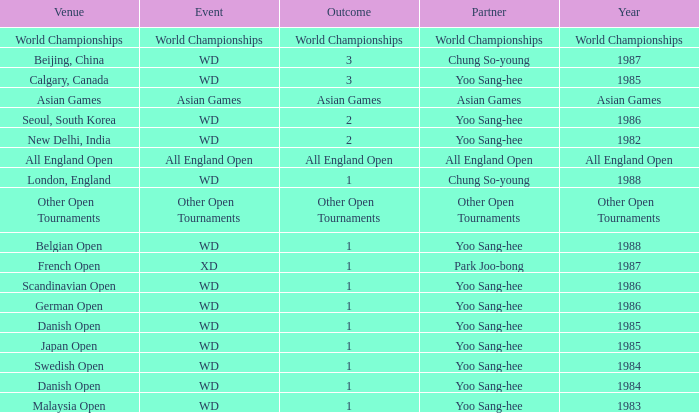What is the Partner during the Asian Games Year? Asian Games. 